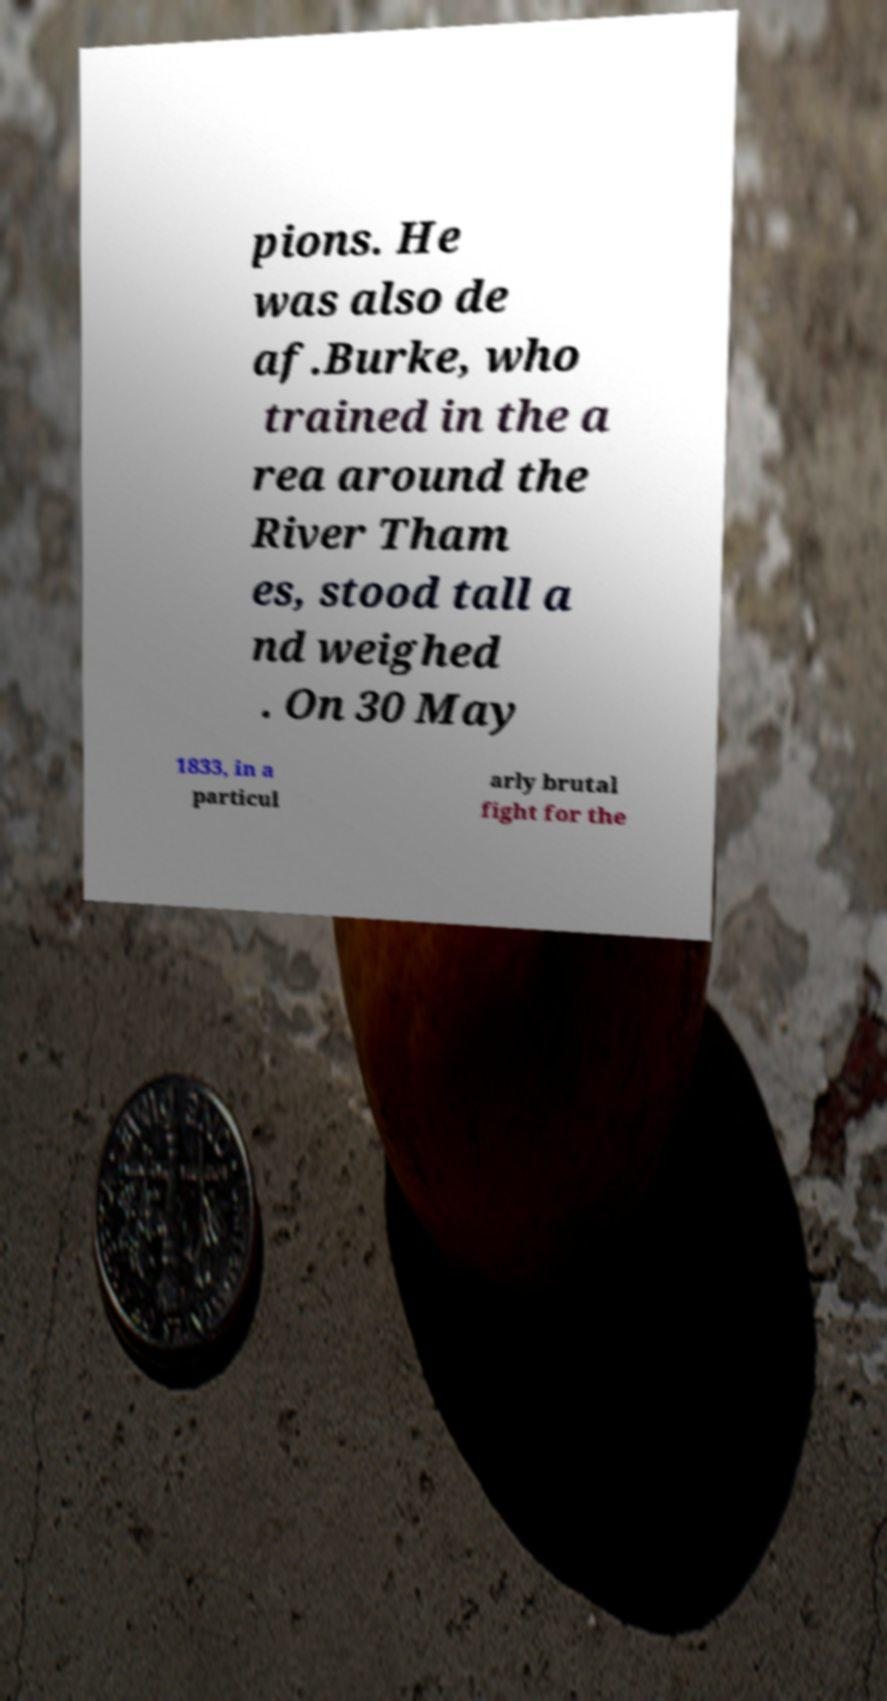I need the written content from this picture converted into text. Can you do that? pions. He was also de af.Burke, who trained in the a rea around the River Tham es, stood tall a nd weighed . On 30 May 1833, in a particul arly brutal fight for the 